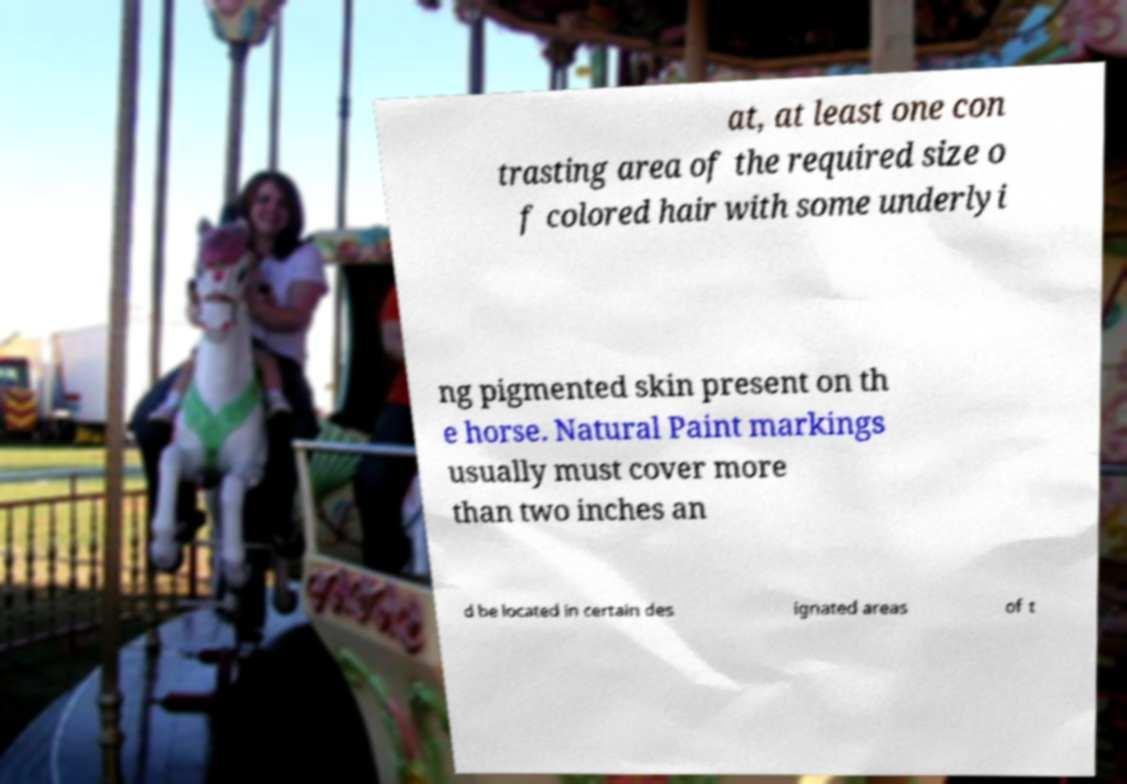Please read and relay the text visible in this image. What does it say? at, at least one con trasting area of the required size o f colored hair with some underlyi ng pigmented skin present on th e horse. Natural Paint markings usually must cover more than two inches an d be located in certain des ignated areas of t 